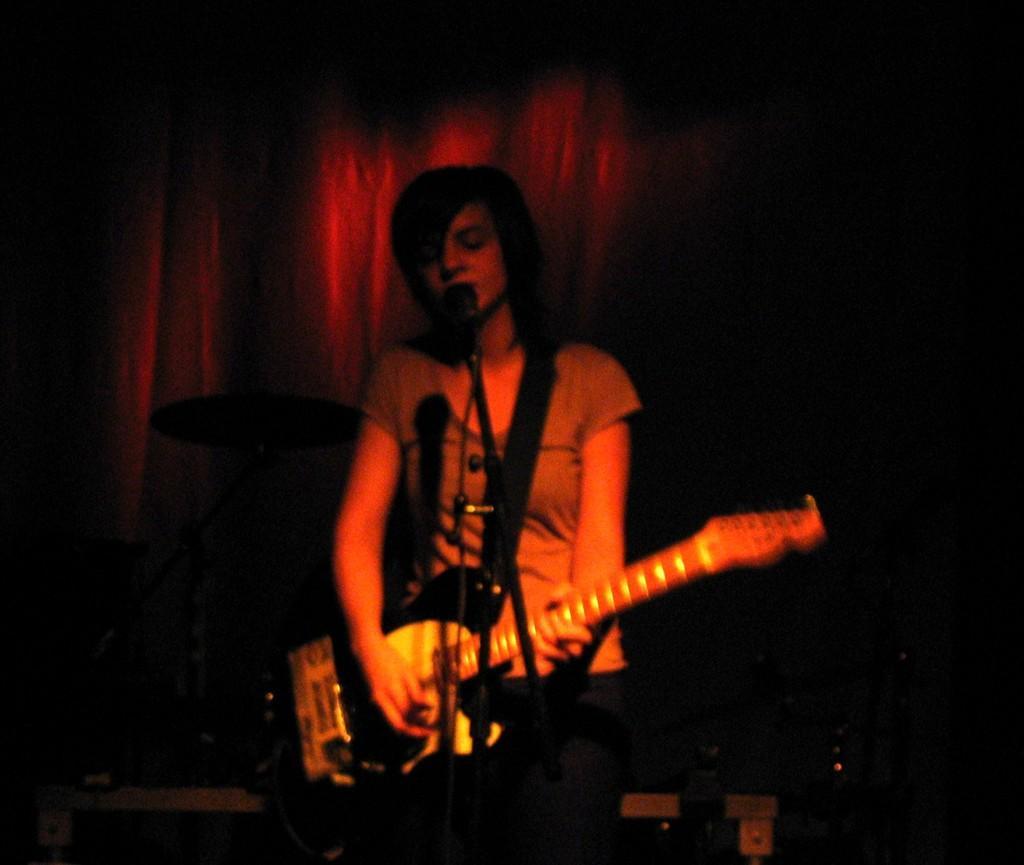Could you give a brief overview of what you see in this image? This image consists of a person who is holding guitar and a mike it is in front of her. She is singing something. drums are placed on the left side and behind her there is a curtain. There are some boxes in the bottom. 